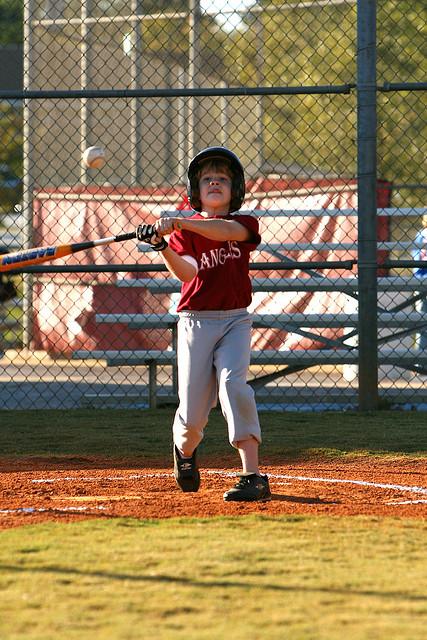What game is he playing?
Short answer required. Baseball. Is this an adult?
Give a very brief answer. No. Is there grass on the field?
Be succinct. Yes. Is there an audience?
Concise answer only. No. What color is the grass?
Write a very short answer. Green. 